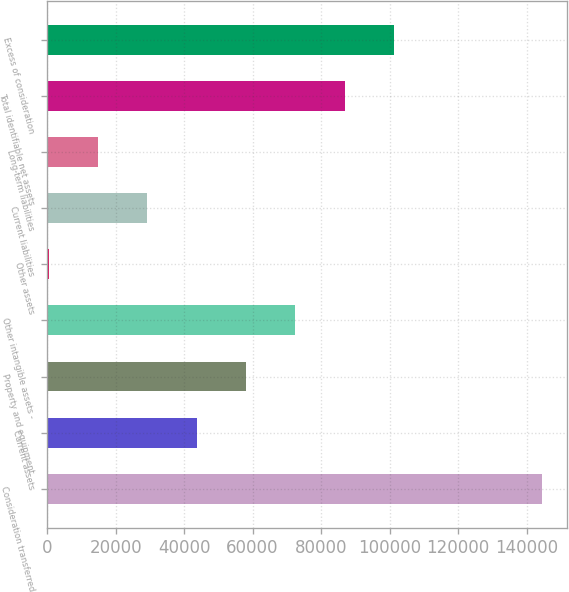Convert chart to OTSL. <chart><loc_0><loc_0><loc_500><loc_500><bar_chart><fcel>Consideration transferred<fcel>Current assets<fcel>Property and equipment<fcel>Other intangible assets -<fcel>Other assets<fcel>Current liabilities<fcel>Long-term liabilities<fcel>Total identifiable net assets<fcel>Excess of consideration<nl><fcel>144476<fcel>43642.4<fcel>58047.2<fcel>72452<fcel>428<fcel>29237.6<fcel>14832.8<fcel>86856.8<fcel>101262<nl></chart> 